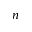Convert formula to latex. <formula><loc_0><loc_0><loc_500><loc_500>n</formula> 